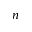Convert formula to latex. <formula><loc_0><loc_0><loc_500><loc_500>n</formula> 